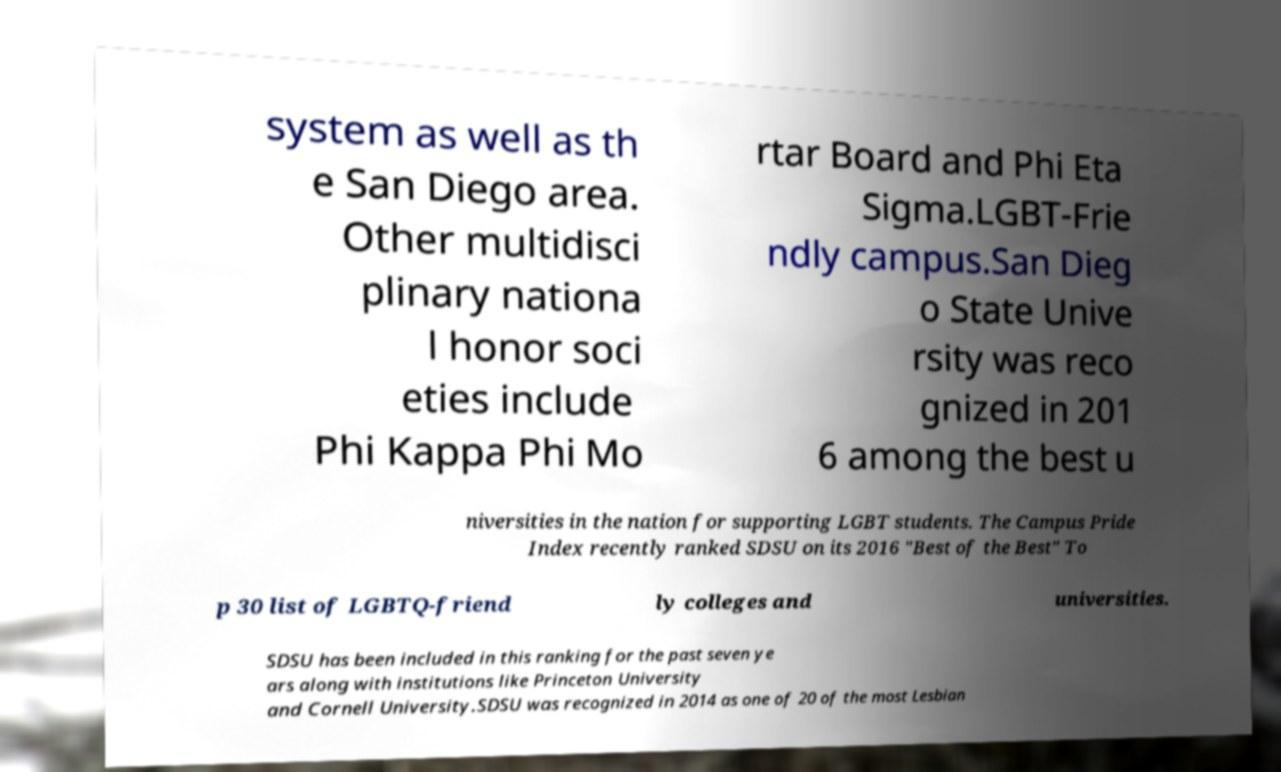For documentation purposes, I need the text within this image transcribed. Could you provide that? system as well as th e San Diego area. Other multidisci plinary nationa l honor soci eties include Phi Kappa Phi Mo rtar Board and Phi Eta Sigma.LGBT-Frie ndly campus.San Dieg o State Unive rsity was reco gnized in 201 6 among the best u niversities in the nation for supporting LGBT students. The Campus Pride Index recently ranked SDSU on its 2016 "Best of the Best" To p 30 list of LGBTQ-friend ly colleges and universities. SDSU has been included in this ranking for the past seven ye ars along with institutions like Princeton University and Cornell University.SDSU was recognized in 2014 as one of 20 of the most Lesbian 